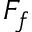<formula> <loc_0><loc_0><loc_500><loc_500>F _ { f }</formula> 